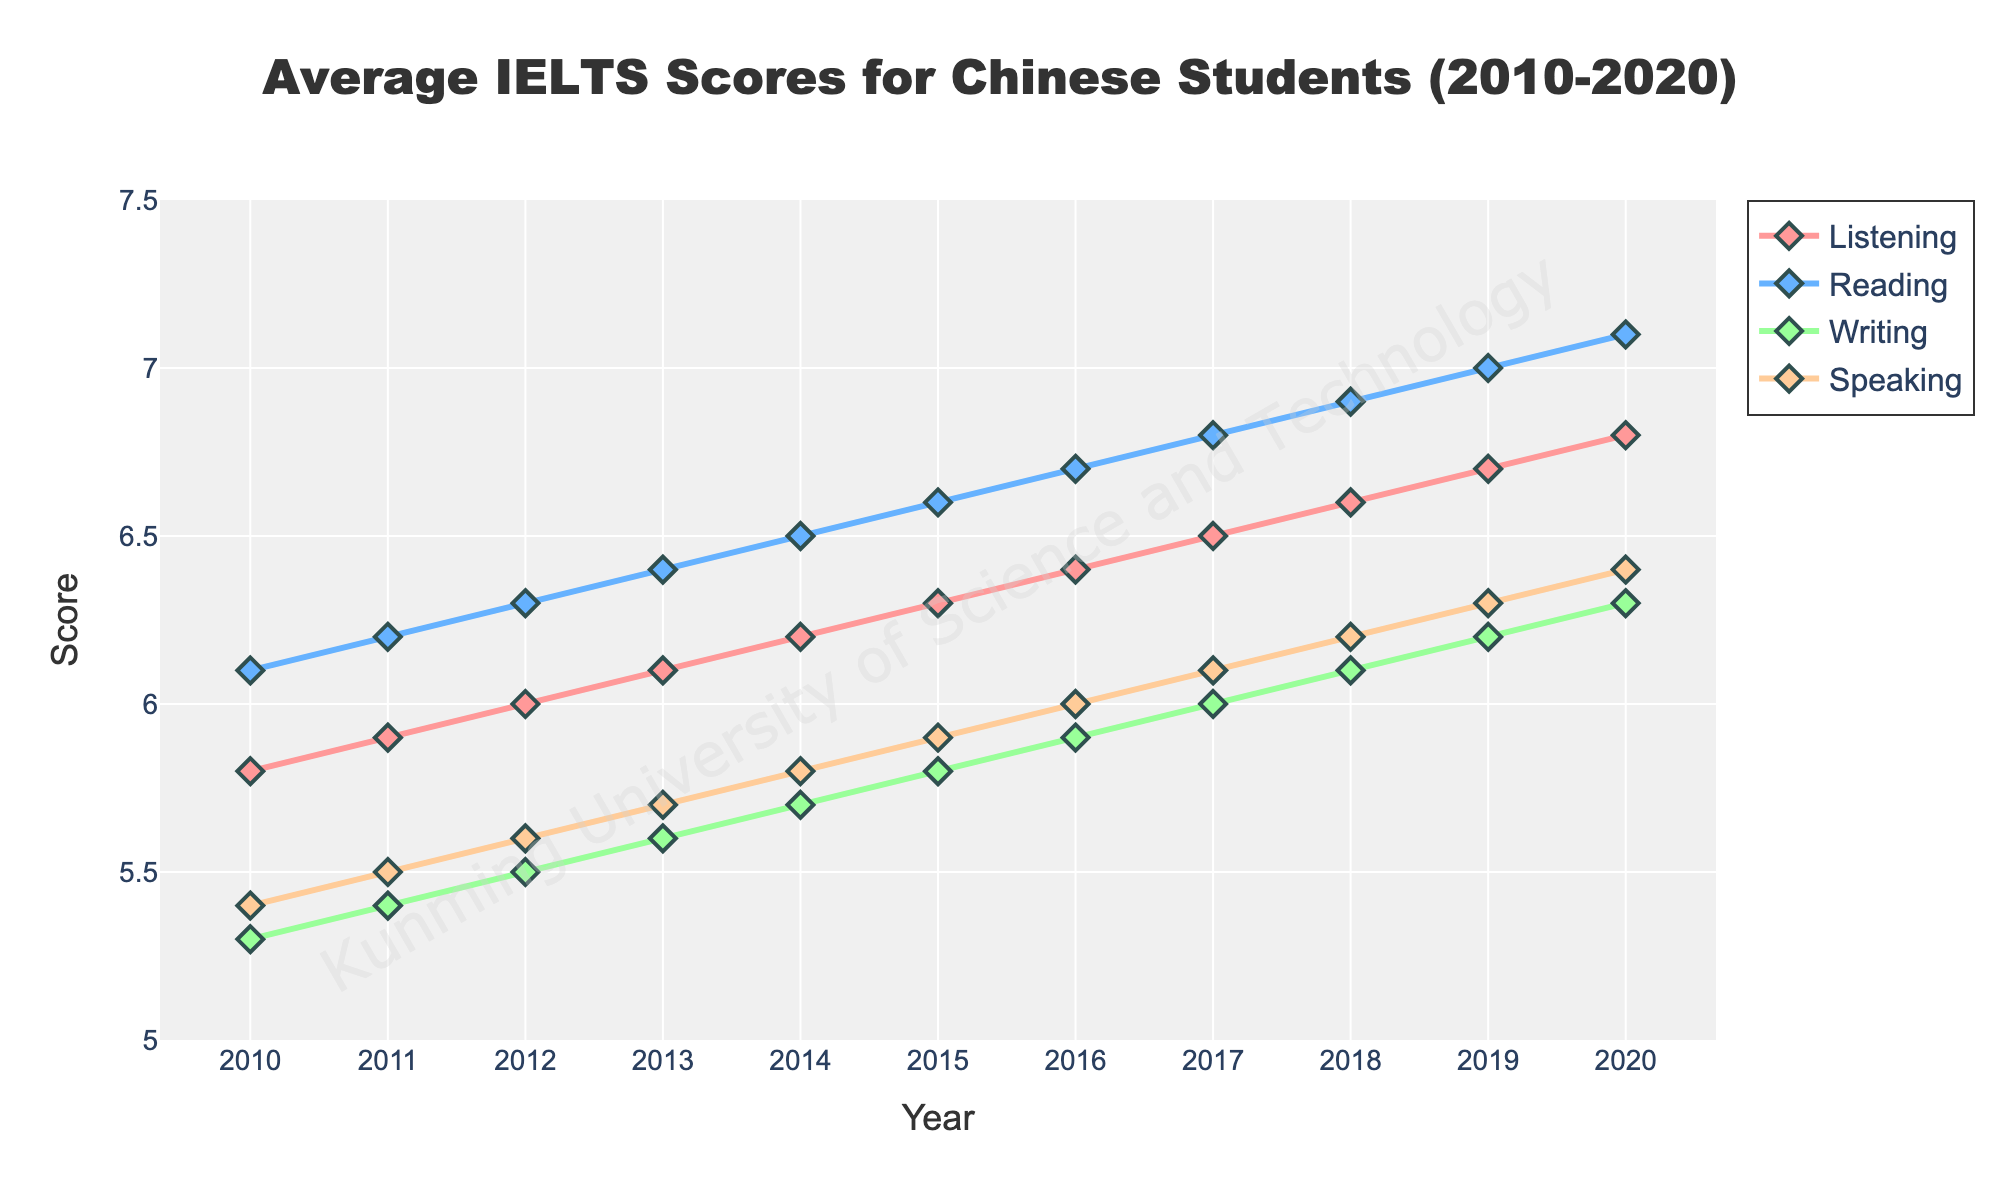What is the trend in the Listening scores from 2010 to 2020? The Listening scores show a continuous upward trend from 5.8 in 2010 to 6.8 in 2020. This can be observed as the line for Listening consistently rises each year.
Answer: Continuous upward trend Which test section has the highest score in 2015? In 2015, the Reading section shows the highest score at 6.6. This can be determined by comparing the heights of the lines corresponding to each test section in that year.
Answer: Reading By how much did the Writing score improve from 2010 to 2020? The Writing score improved from 5.3 in 2010 to 6.3 in 2020. The improvement can be calculated as 6.3 - 5.3 = 1.0.
Answer: 1.0 In which year did the Speaking score surpass 6.0 for the first time? The Speaking score surpassed 6.0 for the first time in 2016, as seen from the figure where the Speaking score goes from being under 6.0 in 2015 to over 6.0 in 2016.
Answer: 2016 Compare the rate of increase in Listening scores to Reading scores from 2010 to 2020. Which increased faster? The Listening scores increased from 5.8 to 6.8, an increase of 1.0, while the Reading scores increased from 6.1 to 7.1, an increase of 1.0 as well. However, since both have the same rate of increase over the same period (1.0 over ten years), neither increased faster.
Answer: Neither What is the visual pattern observed between Listening and Speaking scores over the years? The Listening scores show a consistent and steady upward trend, while the Speaking scores also rise but at a slightly slower and more irregular pace. This can be seen by comparing the smoothness and steepness of the two lines.
Answer: Steadily upward for Listening, slower and more irregular for Speaking Between 2014 and 2016, what was the change in the Reading score? The Reading score increased from 6.5 in 2014 to 6.7 in 2016. The change can be calculated as 6.7 - 6.5 = 0.2.
Answer: 0.2 Which test section shows the smallest growth in scores from 2010 to 2020? The Writing section shows the smallest growth, increasing from 5.3 in 2010 to 6.3 in 2020, a change of 1.0, which is less compared to the other sections like Reading or Listening.
Answer: Writing 